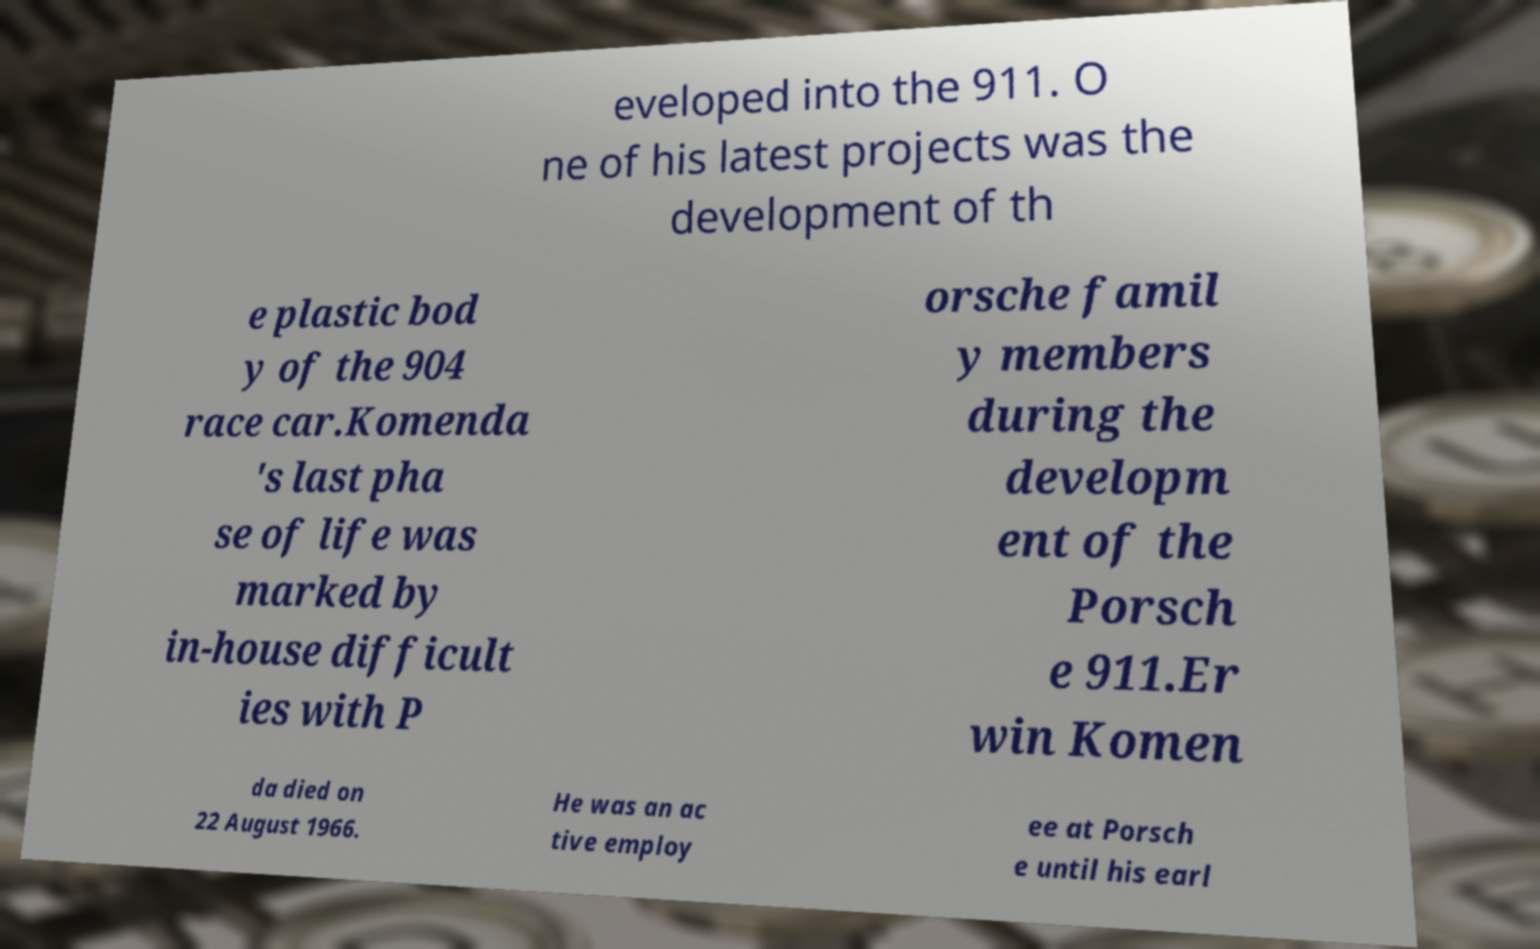There's text embedded in this image that I need extracted. Can you transcribe it verbatim? eveloped into the 911. O ne of his latest projects was the development of th e plastic bod y of the 904 race car.Komenda 's last pha se of life was marked by in-house difficult ies with P orsche famil y members during the developm ent of the Porsch e 911.Er win Komen da died on 22 August 1966. He was an ac tive employ ee at Porsch e until his earl 